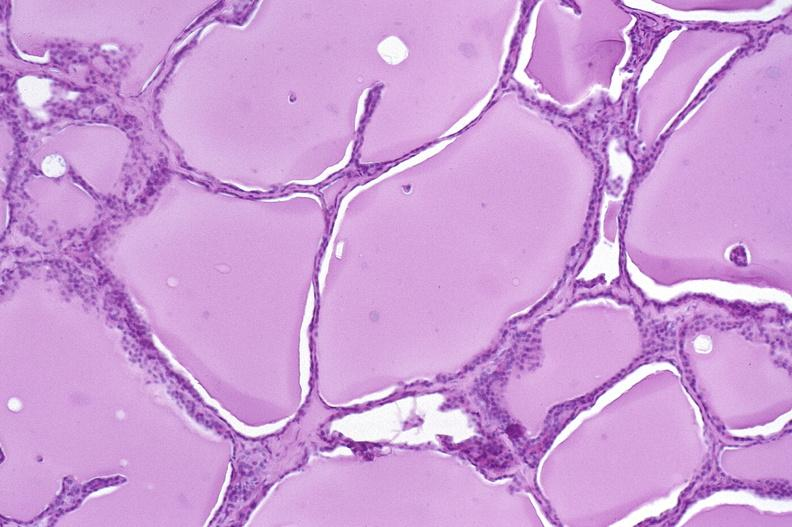what is present?
Answer the question using a single word or phrase. Endocrine 